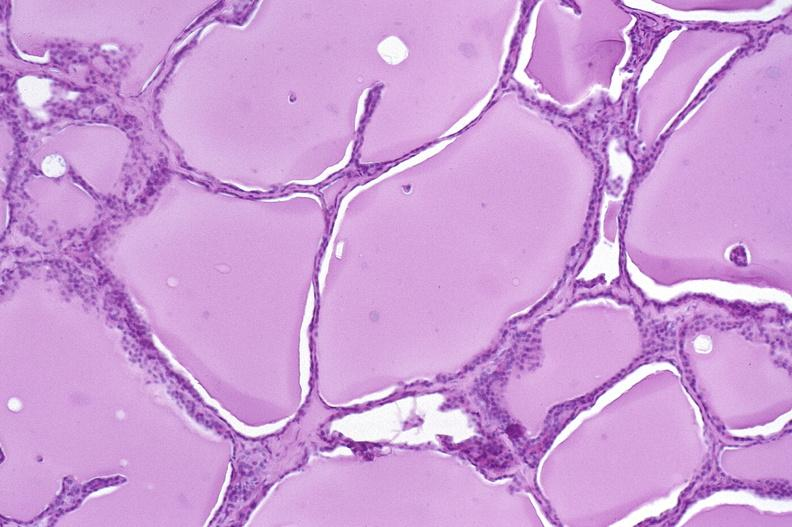what is present?
Answer the question using a single word or phrase. Endocrine 